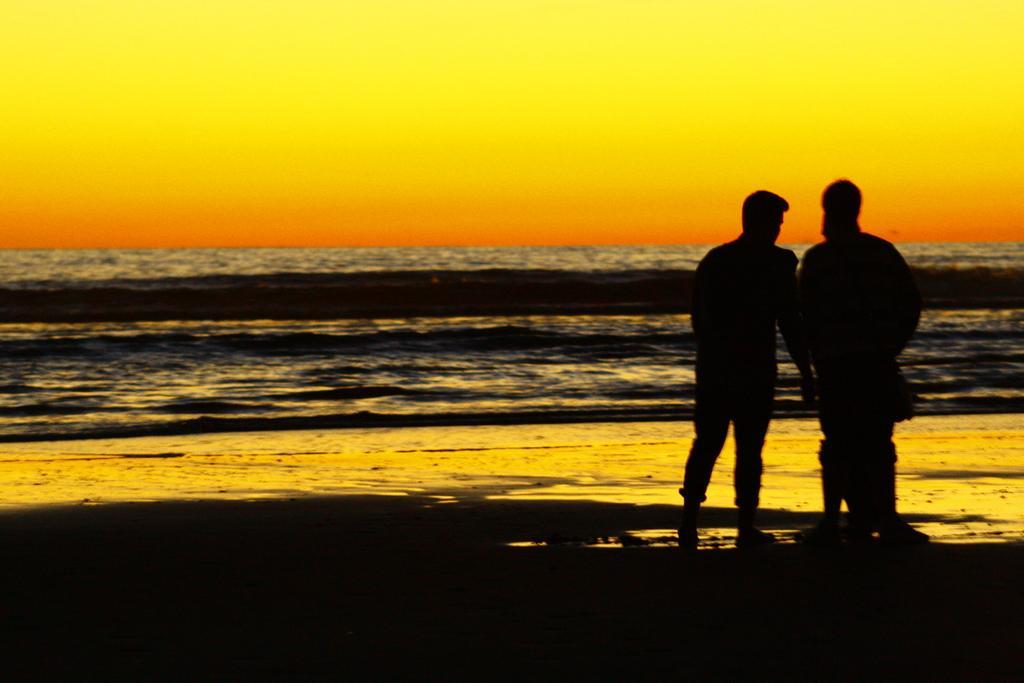In one or two sentences, can you explain what this image depicts? This picture is taken from outside of the city. In this image, on the right side, we can see two men are standing on the sand. In the background, we can see a water in an ocean. At the top, we can see a sky which is yellow and orange color, at the bottom, we can see black color. 